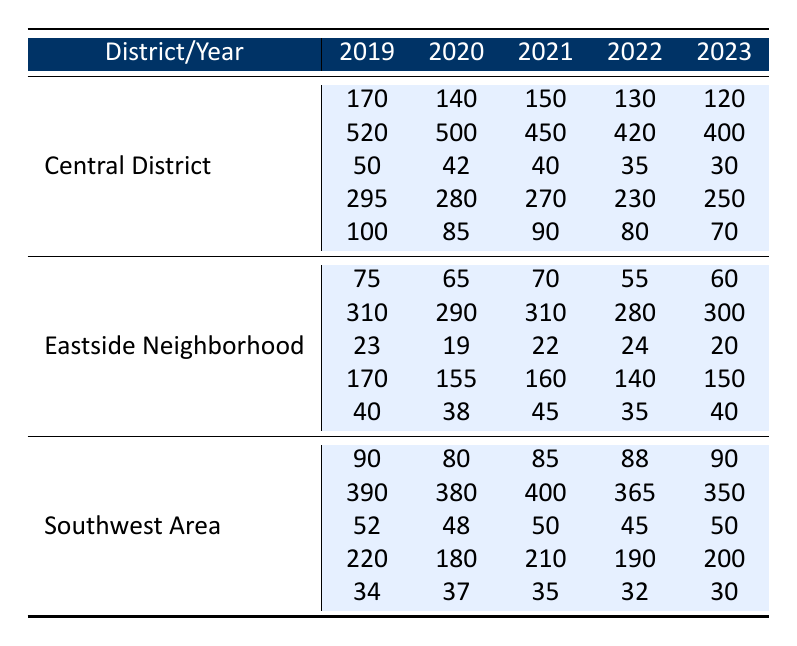What was the total number of violent crimes reported in Central District in 2022? In 2022, the number of violent crimes in Central District was 130.
Answer: 130 How many drug offenses were reported in the Eastside Neighborhood in 2021? In 2021, there were 22 drug offenses reported in Eastside Neighborhood.
Answer: 22 What was the average number of property crimes in the Southwest Area over the last five years? The property crimes in the Southwest Area for the last five years are: 390 (2019), 380 (2020), 400 (2021), 365 (2022), 350 (2023). The average is (390 + 380 + 400 + 365 + 350) / 5 = 377
Answer: 377 Did the number of violent crimes in Central District increase or decrease from 2021 to 2022? The number of violent crimes in Central District decreased from 150 in 2021 to 130 in 2022.
Answer: Decrease What is the total number of theft incidents reported in Eastside Neighborhood from 2019 to 2023? The total theft incidents are: 170 (2019), 155 (2020), 160 (2021), 140 (2022), and 150 (2023). The total is 170 + 155 + 160 + 140 + 150 = 775.
Answer: 775 Which district reported the highest number of drug offenses in 2020, and what was that number? In 2020, the district with the highest number of drug offenses was Central District with 42 offenses.
Answer: Central District, 42 How does the total number of burglaries in Southwest Area in 2023 compare to the total in 2019? In 2019, there were 34 burglaries, and in 2023, there were 30. The number decreased by 4.
Answer: Decrease by 4 What was the trend in violent crimes in Eastside Neighborhood from 2019 to 2023? The violent crimes from 2019 to 2023 were: 75, 65, 70, 55, and 60, showing a general decrease and fluctuation over the years.
Answer: Generally decreasing What was the difference in the number of property crimes between Central District and Southwest Area in 2021? In 2021, Central District reported 450 property crimes, and Southwest Area reported 400, so the difference is 450 - 400 = 50.
Answer: 50 What is the most recent year in which the number of drug offenses in Eastside Neighborhood exceeded 20? In 2021, the number of drug offenses was 22, which is the most recent year exceeding 20.
Answer: 2021 